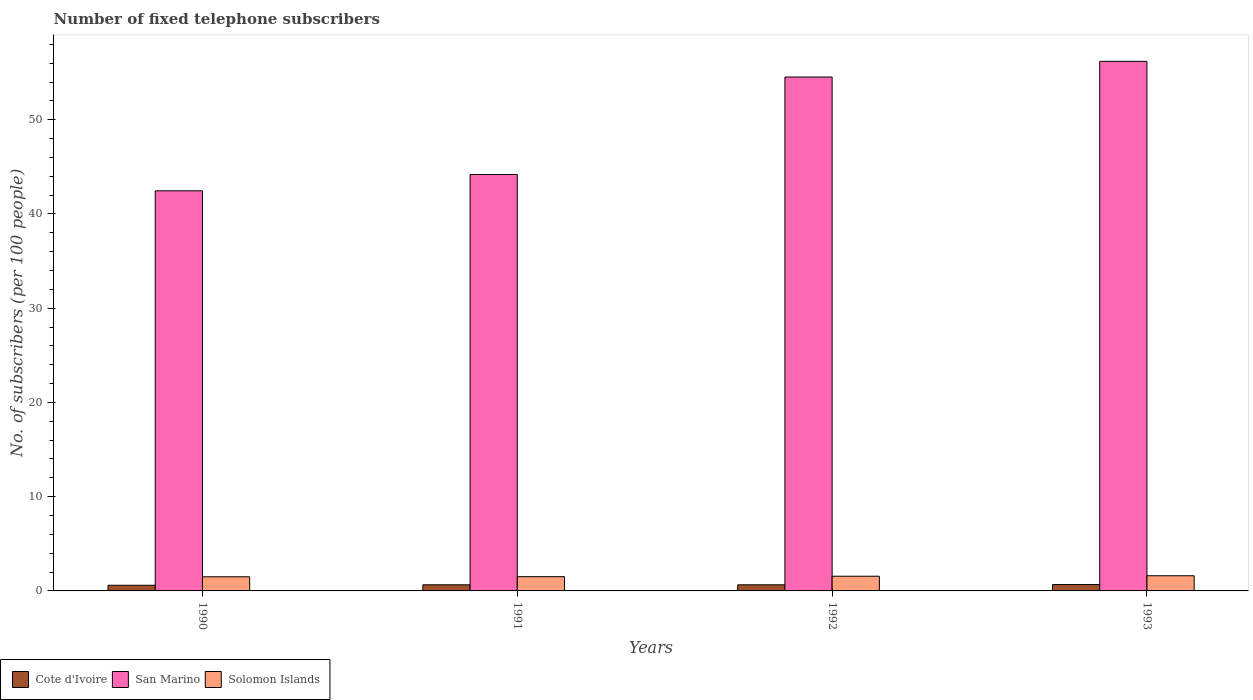How many groups of bars are there?
Offer a terse response. 4. How many bars are there on the 3rd tick from the left?
Make the answer very short. 3. How many bars are there on the 2nd tick from the right?
Provide a succinct answer. 3. In how many cases, is the number of bars for a given year not equal to the number of legend labels?
Make the answer very short. 0. What is the number of fixed telephone subscribers in Cote d'Ivoire in 1991?
Ensure brevity in your answer.  0.65. Across all years, what is the maximum number of fixed telephone subscribers in Cote d'Ivoire?
Provide a succinct answer. 0.67. Across all years, what is the minimum number of fixed telephone subscribers in San Marino?
Make the answer very short. 42.45. What is the total number of fixed telephone subscribers in San Marino in the graph?
Your answer should be very brief. 197.36. What is the difference between the number of fixed telephone subscribers in San Marino in 1992 and that in 1993?
Make the answer very short. -1.66. What is the difference between the number of fixed telephone subscribers in Cote d'Ivoire in 1993 and the number of fixed telephone subscribers in Solomon Islands in 1990?
Your answer should be very brief. -0.83. What is the average number of fixed telephone subscribers in Solomon Islands per year?
Offer a terse response. 1.54. In the year 1992, what is the difference between the number of fixed telephone subscribers in San Marino and number of fixed telephone subscribers in Solomon Islands?
Provide a short and direct response. 52.97. In how many years, is the number of fixed telephone subscribers in San Marino greater than 8?
Offer a very short reply. 4. What is the ratio of the number of fixed telephone subscribers in San Marino in 1990 to that in 1992?
Provide a short and direct response. 0.78. Is the difference between the number of fixed telephone subscribers in San Marino in 1991 and 1992 greater than the difference between the number of fixed telephone subscribers in Solomon Islands in 1991 and 1992?
Your answer should be compact. No. What is the difference between the highest and the second highest number of fixed telephone subscribers in Cote d'Ivoire?
Your answer should be very brief. 0.03. What is the difference between the highest and the lowest number of fixed telephone subscribers in Cote d'Ivoire?
Make the answer very short. 0.07. In how many years, is the number of fixed telephone subscribers in Solomon Islands greater than the average number of fixed telephone subscribers in Solomon Islands taken over all years?
Offer a very short reply. 2. What does the 1st bar from the left in 1992 represents?
Your response must be concise. Cote d'Ivoire. What does the 2nd bar from the right in 1990 represents?
Your response must be concise. San Marino. What is the difference between two consecutive major ticks on the Y-axis?
Offer a terse response. 10. Are the values on the major ticks of Y-axis written in scientific E-notation?
Give a very brief answer. No. Does the graph contain any zero values?
Provide a short and direct response. No. How many legend labels are there?
Your answer should be compact. 3. What is the title of the graph?
Your answer should be very brief. Number of fixed telephone subscribers. What is the label or title of the X-axis?
Provide a short and direct response. Years. What is the label or title of the Y-axis?
Give a very brief answer. No. of subscribers (per 100 people). What is the No. of subscribers (per 100 people) of Cote d'Ivoire in 1990?
Your response must be concise. 0.6. What is the No. of subscribers (per 100 people) of San Marino in 1990?
Your answer should be compact. 42.45. What is the No. of subscribers (per 100 people) of Solomon Islands in 1990?
Give a very brief answer. 1.5. What is the No. of subscribers (per 100 people) in Cote d'Ivoire in 1991?
Provide a short and direct response. 0.65. What is the No. of subscribers (per 100 people) of San Marino in 1991?
Give a very brief answer. 44.19. What is the No. of subscribers (per 100 people) of Solomon Islands in 1991?
Offer a very short reply. 1.51. What is the No. of subscribers (per 100 people) in Cote d'Ivoire in 1992?
Ensure brevity in your answer.  0.65. What is the No. of subscribers (per 100 people) of San Marino in 1992?
Make the answer very short. 54.53. What is the No. of subscribers (per 100 people) in Solomon Islands in 1992?
Your answer should be very brief. 1.56. What is the No. of subscribers (per 100 people) in Cote d'Ivoire in 1993?
Offer a very short reply. 0.67. What is the No. of subscribers (per 100 people) in San Marino in 1993?
Ensure brevity in your answer.  56.19. What is the No. of subscribers (per 100 people) in Solomon Islands in 1993?
Your answer should be very brief. 1.61. Across all years, what is the maximum No. of subscribers (per 100 people) of Cote d'Ivoire?
Your answer should be very brief. 0.67. Across all years, what is the maximum No. of subscribers (per 100 people) in San Marino?
Your answer should be very brief. 56.19. Across all years, what is the maximum No. of subscribers (per 100 people) of Solomon Islands?
Your answer should be very brief. 1.61. Across all years, what is the minimum No. of subscribers (per 100 people) in Cote d'Ivoire?
Your answer should be very brief. 0.6. Across all years, what is the minimum No. of subscribers (per 100 people) in San Marino?
Make the answer very short. 42.45. Across all years, what is the minimum No. of subscribers (per 100 people) of Solomon Islands?
Your answer should be very brief. 1.5. What is the total No. of subscribers (per 100 people) in Cote d'Ivoire in the graph?
Ensure brevity in your answer.  2.57. What is the total No. of subscribers (per 100 people) in San Marino in the graph?
Your answer should be compact. 197.36. What is the total No. of subscribers (per 100 people) of Solomon Islands in the graph?
Your answer should be compact. 6.18. What is the difference between the No. of subscribers (per 100 people) in Cote d'Ivoire in 1990 and that in 1991?
Provide a succinct answer. -0.05. What is the difference between the No. of subscribers (per 100 people) in San Marino in 1990 and that in 1991?
Keep it short and to the point. -1.74. What is the difference between the No. of subscribers (per 100 people) of Solomon Islands in 1990 and that in 1991?
Keep it short and to the point. -0.01. What is the difference between the No. of subscribers (per 100 people) in Cote d'Ivoire in 1990 and that in 1992?
Your answer should be very brief. -0.05. What is the difference between the No. of subscribers (per 100 people) of San Marino in 1990 and that in 1992?
Offer a very short reply. -12.07. What is the difference between the No. of subscribers (per 100 people) of Solomon Islands in 1990 and that in 1992?
Keep it short and to the point. -0.06. What is the difference between the No. of subscribers (per 100 people) in Cote d'Ivoire in 1990 and that in 1993?
Give a very brief answer. -0.07. What is the difference between the No. of subscribers (per 100 people) in San Marino in 1990 and that in 1993?
Offer a terse response. -13.74. What is the difference between the No. of subscribers (per 100 people) in Solomon Islands in 1990 and that in 1993?
Offer a very short reply. -0.11. What is the difference between the No. of subscribers (per 100 people) of Cote d'Ivoire in 1991 and that in 1992?
Your response must be concise. 0. What is the difference between the No. of subscribers (per 100 people) in San Marino in 1991 and that in 1992?
Your answer should be compact. -10.34. What is the difference between the No. of subscribers (per 100 people) in Solomon Islands in 1991 and that in 1992?
Make the answer very short. -0.05. What is the difference between the No. of subscribers (per 100 people) of Cote d'Ivoire in 1991 and that in 1993?
Offer a very short reply. -0.03. What is the difference between the No. of subscribers (per 100 people) of San Marino in 1991 and that in 1993?
Make the answer very short. -12. What is the difference between the No. of subscribers (per 100 people) of Solomon Islands in 1991 and that in 1993?
Keep it short and to the point. -0.1. What is the difference between the No. of subscribers (per 100 people) in Cote d'Ivoire in 1992 and that in 1993?
Your response must be concise. -0.03. What is the difference between the No. of subscribers (per 100 people) of San Marino in 1992 and that in 1993?
Give a very brief answer. -1.66. What is the difference between the No. of subscribers (per 100 people) of Solomon Islands in 1992 and that in 1993?
Provide a short and direct response. -0.05. What is the difference between the No. of subscribers (per 100 people) of Cote d'Ivoire in 1990 and the No. of subscribers (per 100 people) of San Marino in 1991?
Provide a short and direct response. -43.59. What is the difference between the No. of subscribers (per 100 people) in Cote d'Ivoire in 1990 and the No. of subscribers (per 100 people) in Solomon Islands in 1991?
Make the answer very short. -0.91. What is the difference between the No. of subscribers (per 100 people) in San Marino in 1990 and the No. of subscribers (per 100 people) in Solomon Islands in 1991?
Your answer should be compact. 40.94. What is the difference between the No. of subscribers (per 100 people) in Cote d'Ivoire in 1990 and the No. of subscribers (per 100 people) in San Marino in 1992?
Ensure brevity in your answer.  -53.93. What is the difference between the No. of subscribers (per 100 people) of Cote d'Ivoire in 1990 and the No. of subscribers (per 100 people) of Solomon Islands in 1992?
Make the answer very short. -0.96. What is the difference between the No. of subscribers (per 100 people) in San Marino in 1990 and the No. of subscribers (per 100 people) in Solomon Islands in 1992?
Offer a terse response. 40.89. What is the difference between the No. of subscribers (per 100 people) in Cote d'Ivoire in 1990 and the No. of subscribers (per 100 people) in San Marino in 1993?
Your response must be concise. -55.59. What is the difference between the No. of subscribers (per 100 people) in Cote d'Ivoire in 1990 and the No. of subscribers (per 100 people) in Solomon Islands in 1993?
Provide a succinct answer. -1.01. What is the difference between the No. of subscribers (per 100 people) in San Marino in 1990 and the No. of subscribers (per 100 people) in Solomon Islands in 1993?
Ensure brevity in your answer.  40.84. What is the difference between the No. of subscribers (per 100 people) in Cote d'Ivoire in 1991 and the No. of subscribers (per 100 people) in San Marino in 1992?
Make the answer very short. -53.88. What is the difference between the No. of subscribers (per 100 people) in Cote d'Ivoire in 1991 and the No. of subscribers (per 100 people) in Solomon Islands in 1992?
Keep it short and to the point. -0.91. What is the difference between the No. of subscribers (per 100 people) in San Marino in 1991 and the No. of subscribers (per 100 people) in Solomon Islands in 1992?
Provide a short and direct response. 42.63. What is the difference between the No. of subscribers (per 100 people) in Cote d'Ivoire in 1991 and the No. of subscribers (per 100 people) in San Marino in 1993?
Your answer should be very brief. -55.54. What is the difference between the No. of subscribers (per 100 people) in Cote d'Ivoire in 1991 and the No. of subscribers (per 100 people) in Solomon Islands in 1993?
Your answer should be very brief. -0.96. What is the difference between the No. of subscribers (per 100 people) of San Marino in 1991 and the No. of subscribers (per 100 people) of Solomon Islands in 1993?
Provide a succinct answer. 42.58. What is the difference between the No. of subscribers (per 100 people) of Cote d'Ivoire in 1992 and the No. of subscribers (per 100 people) of San Marino in 1993?
Your response must be concise. -55.54. What is the difference between the No. of subscribers (per 100 people) in Cote d'Ivoire in 1992 and the No. of subscribers (per 100 people) in Solomon Islands in 1993?
Offer a very short reply. -0.96. What is the difference between the No. of subscribers (per 100 people) of San Marino in 1992 and the No. of subscribers (per 100 people) of Solomon Islands in 1993?
Your answer should be compact. 52.92. What is the average No. of subscribers (per 100 people) of Cote d'Ivoire per year?
Provide a short and direct response. 0.64. What is the average No. of subscribers (per 100 people) of San Marino per year?
Your answer should be compact. 49.34. What is the average No. of subscribers (per 100 people) of Solomon Islands per year?
Ensure brevity in your answer.  1.54. In the year 1990, what is the difference between the No. of subscribers (per 100 people) of Cote d'Ivoire and No. of subscribers (per 100 people) of San Marino?
Your answer should be compact. -41.85. In the year 1990, what is the difference between the No. of subscribers (per 100 people) in Cote d'Ivoire and No. of subscribers (per 100 people) in Solomon Islands?
Keep it short and to the point. -0.9. In the year 1990, what is the difference between the No. of subscribers (per 100 people) of San Marino and No. of subscribers (per 100 people) of Solomon Islands?
Your answer should be very brief. 40.95. In the year 1991, what is the difference between the No. of subscribers (per 100 people) in Cote d'Ivoire and No. of subscribers (per 100 people) in San Marino?
Offer a terse response. -43.54. In the year 1991, what is the difference between the No. of subscribers (per 100 people) in Cote d'Ivoire and No. of subscribers (per 100 people) in Solomon Islands?
Offer a very short reply. -0.86. In the year 1991, what is the difference between the No. of subscribers (per 100 people) of San Marino and No. of subscribers (per 100 people) of Solomon Islands?
Your answer should be very brief. 42.68. In the year 1992, what is the difference between the No. of subscribers (per 100 people) of Cote d'Ivoire and No. of subscribers (per 100 people) of San Marino?
Your answer should be very brief. -53.88. In the year 1992, what is the difference between the No. of subscribers (per 100 people) of Cote d'Ivoire and No. of subscribers (per 100 people) of Solomon Islands?
Your response must be concise. -0.91. In the year 1992, what is the difference between the No. of subscribers (per 100 people) in San Marino and No. of subscribers (per 100 people) in Solomon Islands?
Give a very brief answer. 52.97. In the year 1993, what is the difference between the No. of subscribers (per 100 people) of Cote d'Ivoire and No. of subscribers (per 100 people) of San Marino?
Provide a succinct answer. -55.52. In the year 1993, what is the difference between the No. of subscribers (per 100 people) in Cote d'Ivoire and No. of subscribers (per 100 people) in Solomon Islands?
Provide a succinct answer. -0.93. In the year 1993, what is the difference between the No. of subscribers (per 100 people) in San Marino and No. of subscribers (per 100 people) in Solomon Islands?
Keep it short and to the point. 54.58. What is the ratio of the No. of subscribers (per 100 people) of Cote d'Ivoire in 1990 to that in 1991?
Your answer should be very brief. 0.93. What is the ratio of the No. of subscribers (per 100 people) of San Marino in 1990 to that in 1991?
Your response must be concise. 0.96. What is the ratio of the No. of subscribers (per 100 people) of Cote d'Ivoire in 1990 to that in 1992?
Keep it short and to the point. 0.93. What is the ratio of the No. of subscribers (per 100 people) of San Marino in 1990 to that in 1992?
Make the answer very short. 0.78. What is the ratio of the No. of subscribers (per 100 people) in Solomon Islands in 1990 to that in 1992?
Offer a terse response. 0.96. What is the ratio of the No. of subscribers (per 100 people) of Cote d'Ivoire in 1990 to that in 1993?
Your answer should be very brief. 0.89. What is the ratio of the No. of subscribers (per 100 people) in San Marino in 1990 to that in 1993?
Your answer should be compact. 0.76. What is the ratio of the No. of subscribers (per 100 people) of Solomon Islands in 1990 to that in 1993?
Provide a short and direct response. 0.93. What is the ratio of the No. of subscribers (per 100 people) of San Marino in 1991 to that in 1992?
Your answer should be compact. 0.81. What is the ratio of the No. of subscribers (per 100 people) of Solomon Islands in 1991 to that in 1992?
Your answer should be very brief. 0.97. What is the ratio of the No. of subscribers (per 100 people) in Cote d'Ivoire in 1991 to that in 1993?
Provide a short and direct response. 0.96. What is the ratio of the No. of subscribers (per 100 people) of San Marino in 1991 to that in 1993?
Give a very brief answer. 0.79. What is the ratio of the No. of subscribers (per 100 people) in Solomon Islands in 1991 to that in 1993?
Your response must be concise. 0.94. What is the ratio of the No. of subscribers (per 100 people) in Cote d'Ivoire in 1992 to that in 1993?
Offer a very short reply. 0.96. What is the ratio of the No. of subscribers (per 100 people) of San Marino in 1992 to that in 1993?
Your response must be concise. 0.97. What is the ratio of the No. of subscribers (per 100 people) in Solomon Islands in 1992 to that in 1993?
Provide a short and direct response. 0.97. What is the difference between the highest and the second highest No. of subscribers (per 100 people) in Cote d'Ivoire?
Your answer should be compact. 0.03. What is the difference between the highest and the second highest No. of subscribers (per 100 people) in San Marino?
Provide a succinct answer. 1.66. What is the difference between the highest and the second highest No. of subscribers (per 100 people) in Solomon Islands?
Offer a very short reply. 0.05. What is the difference between the highest and the lowest No. of subscribers (per 100 people) in Cote d'Ivoire?
Offer a very short reply. 0.07. What is the difference between the highest and the lowest No. of subscribers (per 100 people) of San Marino?
Make the answer very short. 13.74. What is the difference between the highest and the lowest No. of subscribers (per 100 people) in Solomon Islands?
Your response must be concise. 0.11. 